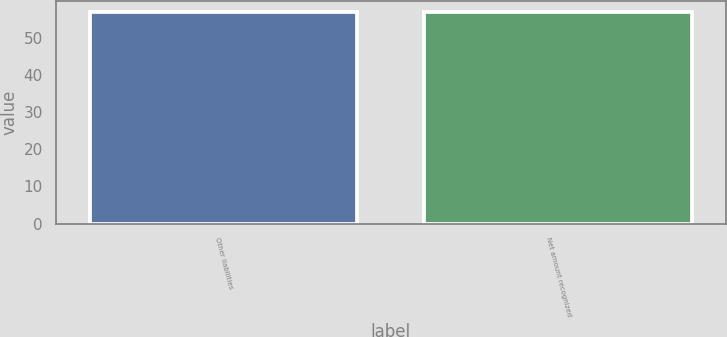Convert chart. <chart><loc_0><loc_0><loc_500><loc_500><bar_chart><fcel>Other liabilities<fcel>Net amount recognized<nl><fcel>57<fcel>57.1<nl></chart> 